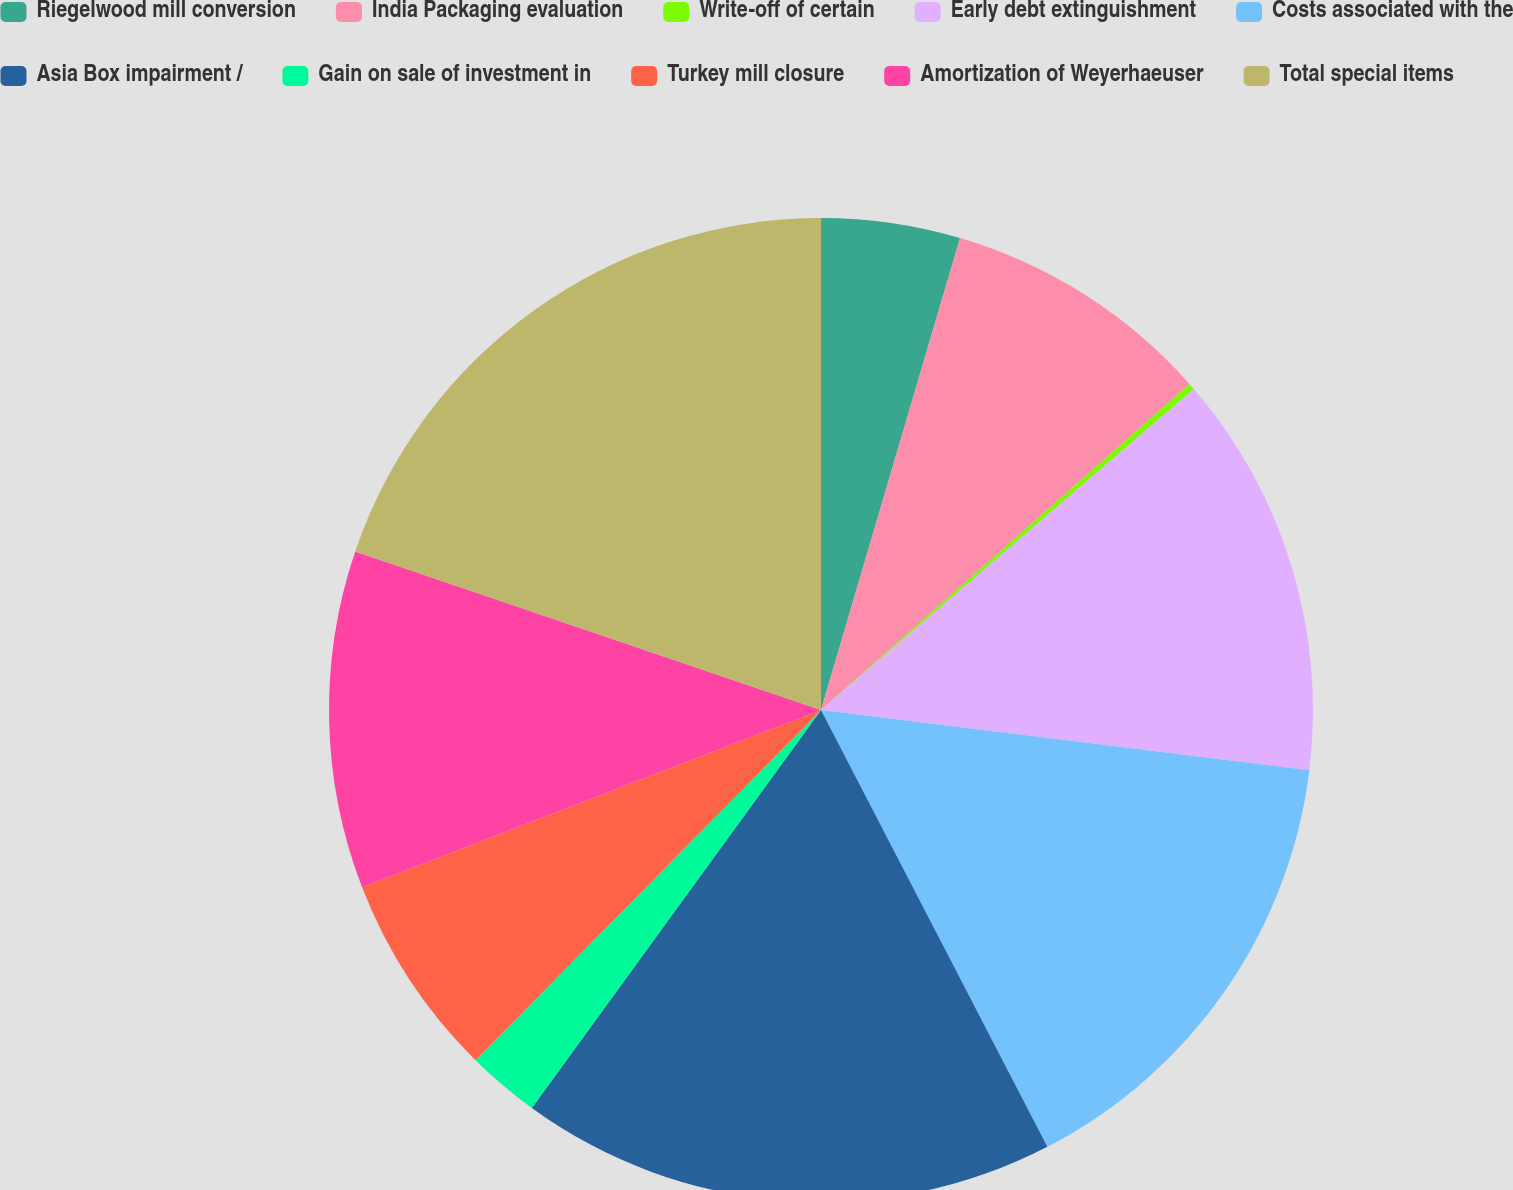Convert chart. <chart><loc_0><loc_0><loc_500><loc_500><pie_chart><fcel>Riegelwood mill conversion<fcel>India Packaging evaluation<fcel>Write-off of certain<fcel>Early debt extinguishment<fcel>Costs associated with the<fcel>Asia Box impairment /<fcel>Gain on sale of investment in<fcel>Turkey mill closure<fcel>Amortization of Weyerhaeuser<fcel>Total special items<nl><fcel>4.56%<fcel>8.91%<fcel>0.22%<fcel>13.26%<fcel>15.44%<fcel>17.61%<fcel>2.39%<fcel>6.74%<fcel>11.09%<fcel>19.78%<nl></chart> 